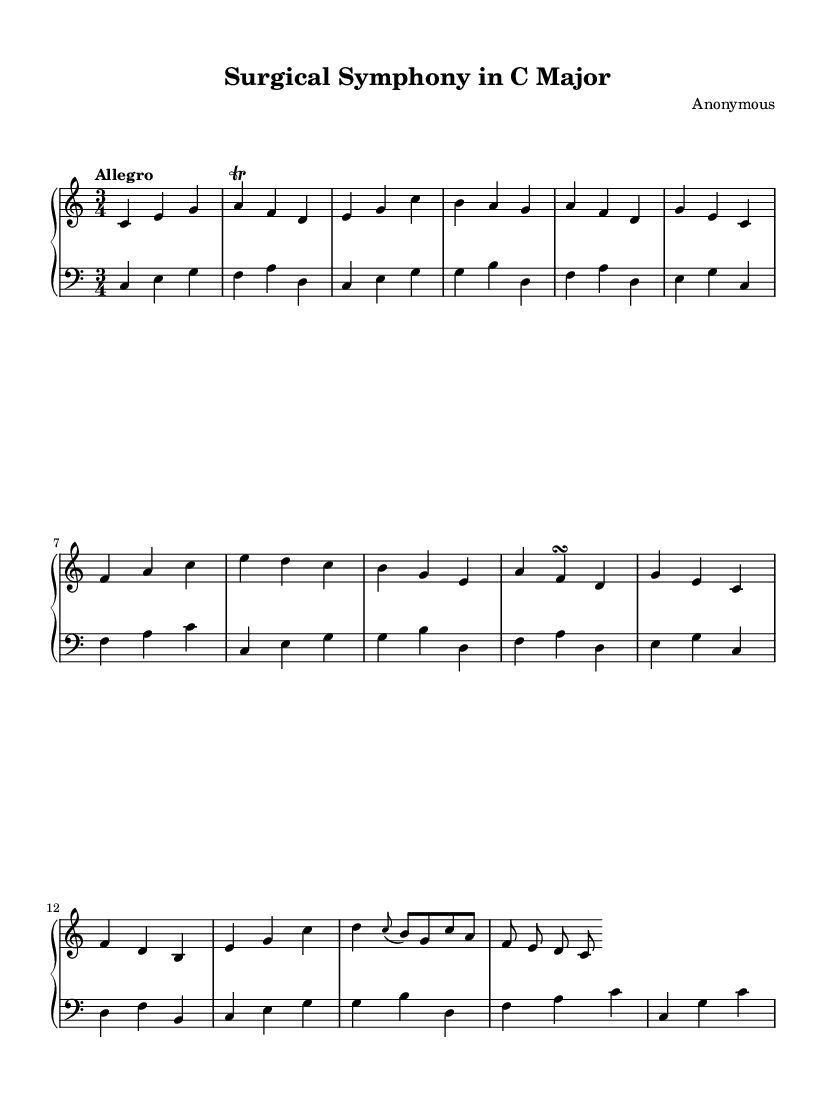What is the key signature of this music? The key signature is C major, which has no sharps or flats.
Answer: C major What is the time signature of this piece? The time signature shown in the music is 3/4, indicating three beats per measure.
Answer: 3/4 What is the tempo marking of this composition? The tempo marking indicates "Allegro", which denotes a fast pace.
Answer: Allegro How many measures are in the left hand section? By counting the measures in the left hand part, there are a total of 14 measures.
Answer: 14 What type of ornamentation is present in the right hand part? The right hand includes a trill ornamentation, marked above the note.
Answer: Trill What is the primary instrument indicated for this score? The instrument specified in the score is the harpsichord, which is indicated for both hands.
Answer: Harpsichord What compositional era does this piece belong to? This piece is composed in the Baroque era, characterized by its polyphony and ornamentation.
Answer: Baroque 